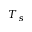Convert formula to latex. <formula><loc_0><loc_0><loc_500><loc_500>T _ { s }</formula> 